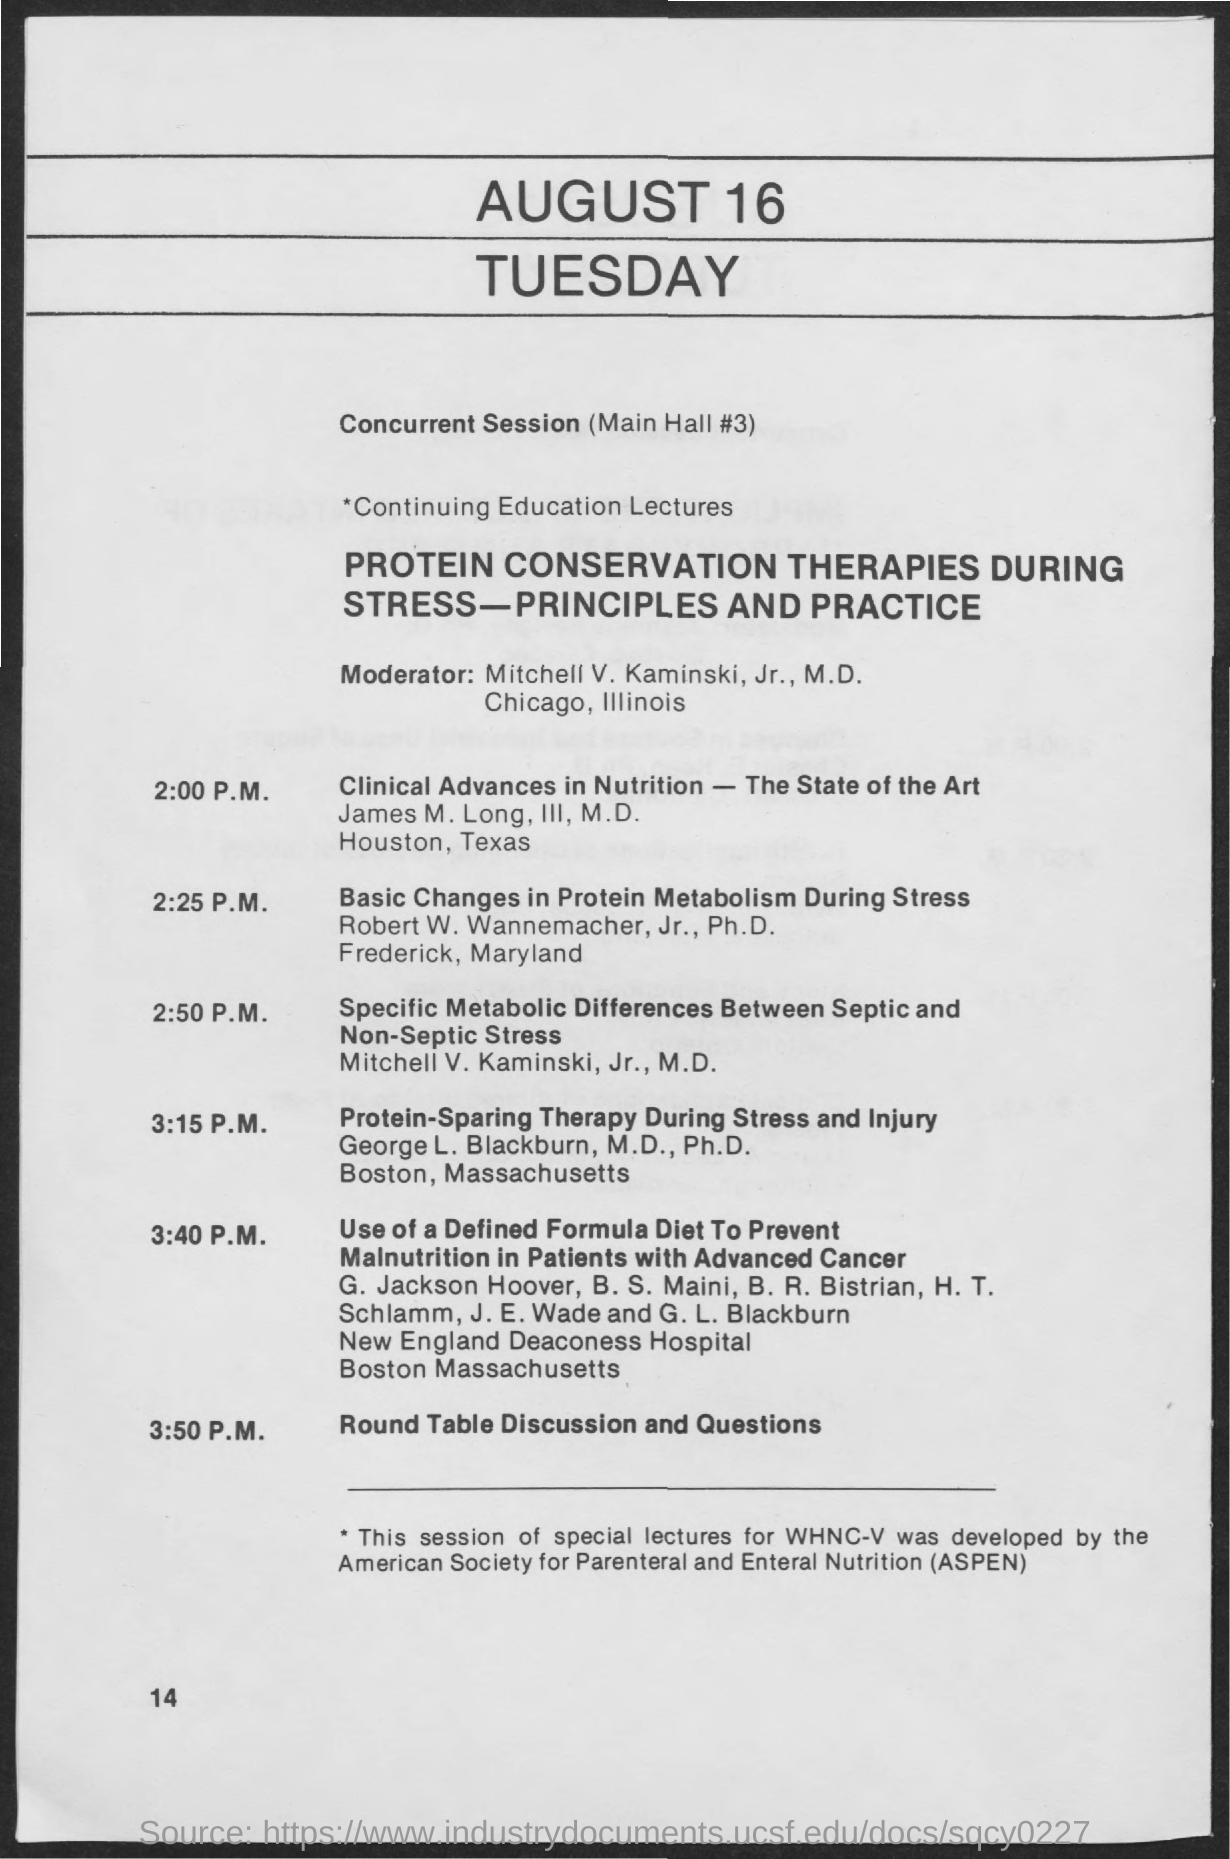Draw attention to some important aspects in this diagram. The lecture is about the topic of protein conservation therapies during stress, specifically focusing on the principles and practices involved. At 3:15 P.M., a lecture titled 'Protein-Sparing Therapy During Stress and Injury' will be taking place. James M. Long, III, M.D. is delivering a lecture on "Clinical Advances in Nutrition - The State of the Art. ASPEN stands for the American Society for Parenteral and Enteral Nutrition, an organization dedicated to promoting advancements in the field of parenteral and enteral nutrition. The moderator is Mitchell V. Kaminski. 